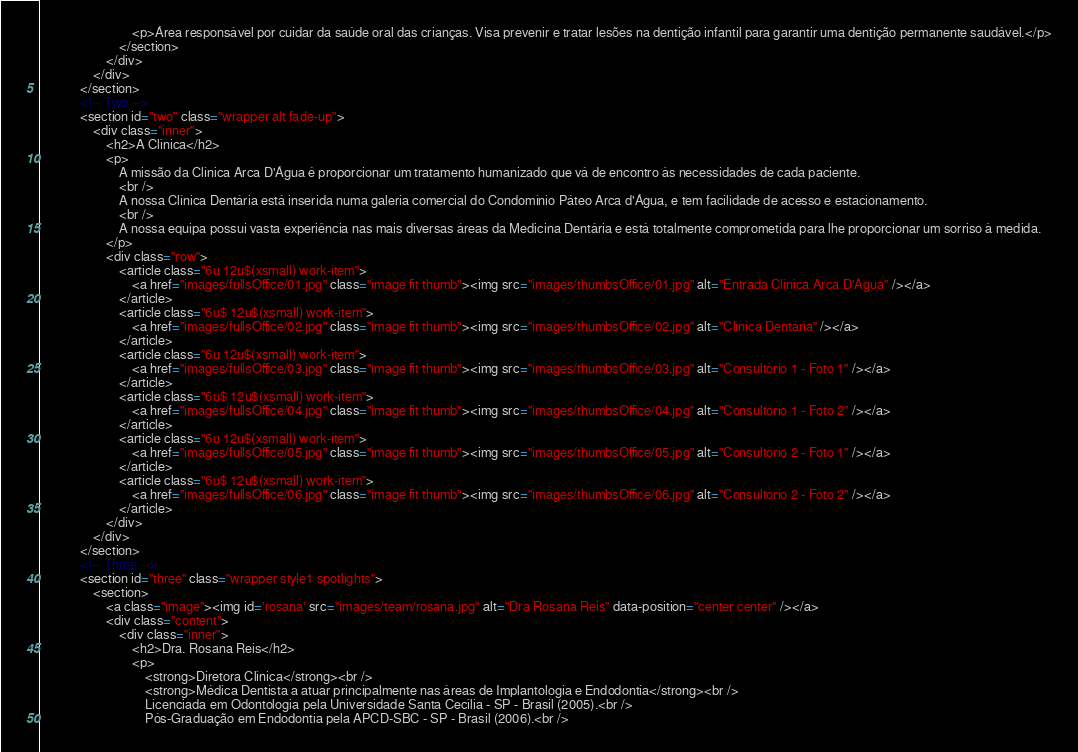<code> <loc_0><loc_0><loc_500><loc_500><_HTML_>                            <p>Área responsável por cuidar da saúde oral das crianças. Visa prevenir e tratar lesões na dentição infantil para garantir uma dentição permanente saudável.</p>
                        </section>
                    </div>
                </div>
            </section>
            <!-- Two -->
            <section id="two" class="wrapper alt fade-up">
                <div class="inner">
                    <h2>A Clínica</h2>
                    <p>
                        A missão da Clínica Arca D'Água é proporcionar um tratamento humanizado que vá de encontro às necessidades de cada paciente.
                        <br />
                        A nossa Clínica Dentária está inserida numa galeria comercial do Condomínio Páteo Arca d'Água, e tem facilidade de acesso e estacionamento.
                        <br />
                        A nossa equipa possui vasta experiência nas mais diversas áreas da Medicina Dentária e está totalmente comprometida para lhe proporcionar um sorriso à medida.
                    </p>
                    <div class="row">
                        <article class="6u 12u$(xsmall) work-item">
                            <a href="images/fullsOffice/01.jpg" class="image fit thumb"><img src="images/thumbsOffice/01.jpg" alt="Entrada Clínica Arca D'Água" /></a>
                        </article>
                        <article class="6u$ 12u$(xsmall) work-item">
                            <a href="images/fullsOffice/02.jpg" class="image fit thumb"><img src="images/thumbsOffice/02.jpg" alt="Clínica Dentária" /></a>
                        </article>
                        <article class="6u 12u$(xsmall) work-item">
                            <a href="images/fullsOffice/03.jpg" class="image fit thumb"><img src="images/thumbsOffice/03.jpg" alt="Consultório 1 - Foto 1" /></a>
                        </article>
                        <article class="6u$ 12u$(xsmall) work-item">
                            <a href="images/fullsOffice/04.jpg" class="image fit thumb"><img src="images/thumbsOffice/04.jpg" alt="Consultório 1 - Foto 2" /></a>
                        </article>
                        <article class="6u 12u$(xsmall) work-item">
                            <a href="images/fullsOffice/05.jpg" class="image fit thumb"><img src="images/thumbsOffice/05.jpg" alt="Consultório 2 - Foto 1" /></a>
                        </article>
                        <article class="6u$ 12u$(xsmall) work-item">
                            <a href="images/fullsOffice/06.jpg" class="image fit thumb"><img src="images/thumbsOffice/06.jpg" alt="Consultório 2 - Foto 2" /></a>
                        </article>
                    </div>
                </div>
            </section>
            <!-- Three -->
            <section id="three" class="wrapper style1 spotlights">
                <section>
                    <a class="image"><img id='rosana' src="images/team/rosana.jpg" alt="Dra Rosana Reis" data-position="center center" /></a>
                    <div class="content">
                        <div class="inner">
                            <h2>Dra. Rosana Reis</h2>
                            <p>
                                <strong>Diretora Clínica</strong><br />
                                <strong>Médica Dentista a atuar principalmente nas áreas de Implantologia e Endodontia</strong><br />
                                Licenciada em Odontologia pela Universidade Santa Cecília - SP - Brasil (2005).<br />
                                Pós-Graduação em Endodontia pela APCD-SBC - SP - Brasil (2006).<br /></code> 